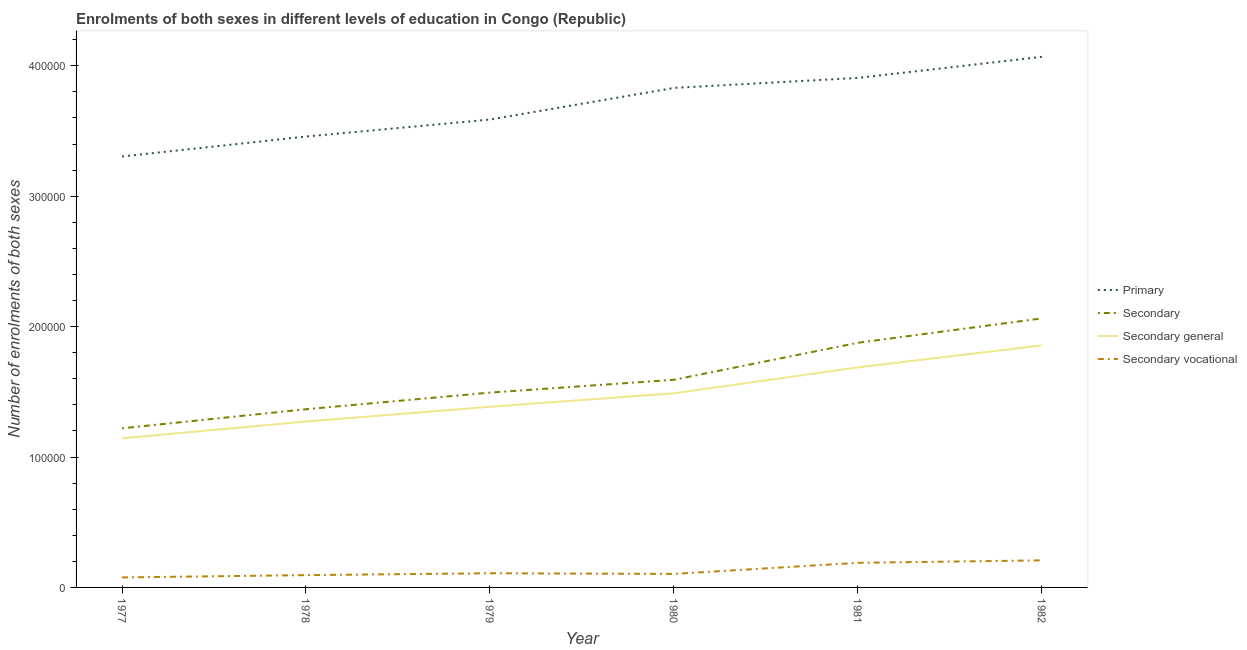How many different coloured lines are there?
Your answer should be very brief. 4. Does the line corresponding to number of enrolments in primary education intersect with the line corresponding to number of enrolments in secondary education?
Keep it short and to the point. No. Is the number of lines equal to the number of legend labels?
Ensure brevity in your answer.  Yes. What is the number of enrolments in primary education in 1978?
Keep it short and to the point. 3.46e+05. Across all years, what is the maximum number of enrolments in secondary vocational education?
Provide a succinct answer. 2.07e+04. Across all years, what is the minimum number of enrolments in secondary education?
Keep it short and to the point. 1.22e+05. In which year was the number of enrolments in secondary education minimum?
Your response must be concise. 1977. What is the total number of enrolments in secondary education in the graph?
Offer a very short reply. 9.61e+05. What is the difference between the number of enrolments in secondary general education in 1979 and that in 1981?
Your response must be concise. -3.02e+04. What is the difference between the number of enrolments in secondary vocational education in 1978 and the number of enrolments in secondary general education in 1980?
Give a very brief answer. -1.39e+05. What is the average number of enrolments in secondary general education per year?
Provide a succinct answer. 1.47e+05. In the year 1981, what is the difference between the number of enrolments in secondary education and number of enrolments in secondary general education?
Ensure brevity in your answer.  1.89e+04. What is the ratio of the number of enrolments in primary education in 1977 to that in 1982?
Offer a very short reply. 0.81. Is the difference between the number of enrolments in secondary education in 1979 and 1981 greater than the difference between the number of enrolments in secondary general education in 1979 and 1981?
Offer a terse response. No. What is the difference between the highest and the second highest number of enrolments in secondary vocational education?
Ensure brevity in your answer.  1877. What is the difference between the highest and the lowest number of enrolments in primary education?
Ensure brevity in your answer.  7.64e+04. Is it the case that in every year, the sum of the number of enrolments in secondary general education and number of enrolments in primary education is greater than the sum of number of enrolments in secondary education and number of enrolments in secondary vocational education?
Your answer should be compact. Yes. What is the difference between two consecutive major ticks on the Y-axis?
Offer a very short reply. 1.00e+05. Does the graph contain any zero values?
Your response must be concise. No. Where does the legend appear in the graph?
Your answer should be very brief. Center right. How many legend labels are there?
Your answer should be very brief. 4. What is the title of the graph?
Make the answer very short. Enrolments of both sexes in different levels of education in Congo (Republic). Does "Social Awareness" appear as one of the legend labels in the graph?
Your response must be concise. No. What is the label or title of the X-axis?
Keep it short and to the point. Year. What is the label or title of the Y-axis?
Your answer should be compact. Number of enrolments of both sexes. What is the Number of enrolments of both sexes of Primary in 1977?
Provide a succinct answer. 3.30e+05. What is the Number of enrolments of both sexes in Secondary in 1977?
Provide a short and direct response. 1.22e+05. What is the Number of enrolments of both sexes in Secondary general in 1977?
Give a very brief answer. 1.14e+05. What is the Number of enrolments of both sexes of Secondary vocational in 1977?
Offer a very short reply. 7665. What is the Number of enrolments of both sexes in Primary in 1978?
Provide a succinct answer. 3.46e+05. What is the Number of enrolments of both sexes in Secondary in 1978?
Make the answer very short. 1.37e+05. What is the Number of enrolments of both sexes of Secondary general in 1978?
Make the answer very short. 1.27e+05. What is the Number of enrolments of both sexes of Secondary vocational in 1978?
Offer a terse response. 9432. What is the Number of enrolments of both sexes of Primary in 1979?
Your response must be concise. 3.59e+05. What is the Number of enrolments of both sexes of Secondary in 1979?
Provide a succinct answer. 1.49e+05. What is the Number of enrolments of both sexes in Secondary general in 1979?
Offer a very short reply. 1.39e+05. What is the Number of enrolments of both sexes of Secondary vocational in 1979?
Your response must be concise. 1.09e+04. What is the Number of enrolments of both sexes in Primary in 1980?
Provide a short and direct response. 3.83e+05. What is the Number of enrolments of both sexes in Secondary in 1980?
Give a very brief answer. 1.59e+05. What is the Number of enrolments of both sexes in Secondary general in 1980?
Keep it short and to the point. 1.49e+05. What is the Number of enrolments of both sexes in Secondary vocational in 1980?
Offer a terse response. 1.04e+04. What is the Number of enrolments of both sexes in Primary in 1981?
Offer a terse response. 3.91e+05. What is the Number of enrolments of both sexes in Secondary in 1981?
Your answer should be very brief. 1.88e+05. What is the Number of enrolments of both sexes in Secondary general in 1981?
Your answer should be compact. 1.69e+05. What is the Number of enrolments of both sexes of Secondary vocational in 1981?
Keep it short and to the point. 1.89e+04. What is the Number of enrolments of both sexes of Primary in 1982?
Your answer should be very brief. 4.07e+05. What is the Number of enrolments of both sexes of Secondary in 1982?
Offer a terse response. 2.06e+05. What is the Number of enrolments of both sexes of Secondary general in 1982?
Provide a short and direct response. 1.86e+05. What is the Number of enrolments of both sexes in Secondary vocational in 1982?
Provide a succinct answer. 2.07e+04. Across all years, what is the maximum Number of enrolments of both sexes in Primary?
Keep it short and to the point. 4.07e+05. Across all years, what is the maximum Number of enrolments of both sexes of Secondary?
Offer a very short reply. 2.06e+05. Across all years, what is the maximum Number of enrolments of both sexes of Secondary general?
Provide a short and direct response. 1.86e+05. Across all years, what is the maximum Number of enrolments of both sexes of Secondary vocational?
Make the answer very short. 2.07e+04. Across all years, what is the minimum Number of enrolments of both sexes in Primary?
Offer a terse response. 3.30e+05. Across all years, what is the minimum Number of enrolments of both sexes of Secondary?
Provide a short and direct response. 1.22e+05. Across all years, what is the minimum Number of enrolments of both sexes in Secondary general?
Ensure brevity in your answer.  1.14e+05. Across all years, what is the minimum Number of enrolments of both sexes in Secondary vocational?
Offer a very short reply. 7665. What is the total Number of enrolments of both sexes of Primary in the graph?
Keep it short and to the point. 2.22e+06. What is the total Number of enrolments of both sexes of Secondary in the graph?
Your answer should be compact. 9.61e+05. What is the total Number of enrolments of both sexes in Secondary general in the graph?
Keep it short and to the point. 8.83e+05. What is the total Number of enrolments of both sexes in Secondary vocational in the graph?
Make the answer very short. 7.79e+04. What is the difference between the Number of enrolments of both sexes in Primary in 1977 and that in 1978?
Make the answer very short. -1.53e+04. What is the difference between the Number of enrolments of both sexes of Secondary in 1977 and that in 1978?
Keep it short and to the point. -1.46e+04. What is the difference between the Number of enrolments of both sexes in Secondary general in 1977 and that in 1978?
Provide a succinct answer. -1.29e+04. What is the difference between the Number of enrolments of both sexes in Secondary vocational in 1977 and that in 1978?
Provide a succinct answer. -1767. What is the difference between the Number of enrolments of both sexes of Primary in 1977 and that in 1979?
Offer a terse response. -2.83e+04. What is the difference between the Number of enrolments of both sexes in Secondary in 1977 and that in 1979?
Make the answer very short. -2.74e+04. What is the difference between the Number of enrolments of both sexes of Secondary general in 1977 and that in 1979?
Make the answer very short. -2.42e+04. What is the difference between the Number of enrolments of both sexes of Secondary vocational in 1977 and that in 1979?
Your answer should be compact. -3196. What is the difference between the Number of enrolments of both sexes in Primary in 1977 and that in 1980?
Give a very brief answer. -5.26e+04. What is the difference between the Number of enrolments of both sexes in Secondary in 1977 and that in 1980?
Keep it short and to the point. -3.72e+04. What is the difference between the Number of enrolments of both sexes of Secondary general in 1977 and that in 1980?
Offer a terse response. -3.45e+04. What is the difference between the Number of enrolments of both sexes of Secondary vocational in 1977 and that in 1980?
Offer a very short reply. -2696. What is the difference between the Number of enrolments of both sexes of Primary in 1977 and that in 1981?
Offer a terse response. -6.02e+04. What is the difference between the Number of enrolments of both sexes of Secondary in 1977 and that in 1981?
Ensure brevity in your answer.  -6.56e+04. What is the difference between the Number of enrolments of both sexes of Secondary general in 1977 and that in 1981?
Provide a short and direct response. -5.44e+04. What is the difference between the Number of enrolments of both sexes of Secondary vocational in 1977 and that in 1981?
Provide a succinct answer. -1.12e+04. What is the difference between the Number of enrolments of both sexes in Primary in 1977 and that in 1982?
Give a very brief answer. -7.64e+04. What is the difference between the Number of enrolments of both sexes of Secondary in 1977 and that in 1982?
Provide a short and direct response. -8.43e+04. What is the difference between the Number of enrolments of both sexes of Secondary general in 1977 and that in 1982?
Your response must be concise. -7.12e+04. What is the difference between the Number of enrolments of both sexes of Secondary vocational in 1977 and that in 1982?
Your answer should be compact. -1.31e+04. What is the difference between the Number of enrolments of both sexes in Primary in 1978 and that in 1979?
Your answer should be compact. -1.30e+04. What is the difference between the Number of enrolments of both sexes of Secondary in 1978 and that in 1979?
Give a very brief answer. -1.27e+04. What is the difference between the Number of enrolments of both sexes of Secondary general in 1978 and that in 1979?
Ensure brevity in your answer.  -1.13e+04. What is the difference between the Number of enrolments of both sexes in Secondary vocational in 1978 and that in 1979?
Provide a short and direct response. -1429. What is the difference between the Number of enrolments of both sexes in Primary in 1978 and that in 1980?
Offer a very short reply. -3.73e+04. What is the difference between the Number of enrolments of both sexes in Secondary in 1978 and that in 1980?
Offer a terse response. -2.26e+04. What is the difference between the Number of enrolments of both sexes in Secondary general in 1978 and that in 1980?
Your answer should be compact. -2.16e+04. What is the difference between the Number of enrolments of both sexes in Secondary vocational in 1978 and that in 1980?
Ensure brevity in your answer.  -929. What is the difference between the Number of enrolments of both sexes in Primary in 1978 and that in 1981?
Your answer should be compact. -4.49e+04. What is the difference between the Number of enrolments of both sexes in Secondary in 1978 and that in 1981?
Offer a very short reply. -5.09e+04. What is the difference between the Number of enrolments of both sexes in Secondary general in 1978 and that in 1981?
Your response must be concise. -4.15e+04. What is the difference between the Number of enrolments of both sexes in Secondary vocational in 1978 and that in 1981?
Offer a terse response. -9435. What is the difference between the Number of enrolments of both sexes of Primary in 1978 and that in 1982?
Give a very brief answer. -6.11e+04. What is the difference between the Number of enrolments of both sexes in Secondary in 1978 and that in 1982?
Your response must be concise. -6.97e+04. What is the difference between the Number of enrolments of both sexes of Secondary general in 1978 and that in 1982?
Make the answer very short. -5.83e+04. What is the difference between the Number of enrolments of both sexes in Secondary vocational in 1978 and that in 1982?
Offer a very short reply. -1.13e+04. What is the difference between the Number of enrolments of both sexes of Primary in 1979 and that in 1980?
Your answer should be compact. -2.43e+04. What is the difference between the Number of enrolments of both sexes in Secondary in 1979 and that in 1980?
Ensure brevity in your answer.  -9832. What is the difference between the Number of enrolments of both sexes of Secondary general in 1979 and that in 1980?
Your answer should be very brief. -1.03e+04. What is the difference between the Number of enrolments of both sexes in Secondary vocational in 1979 and that in 1980?
Your answer should be very brief. 500. What is the difference between the Number of enrolments of both sexes in Primary in 1979 and that in 1981?
Provide a short and direct response. -3.19e+04. What is the difference between the Number of enrolments of both sexes in Secondary in 1979 and that in 1981?
Offer a very short reply. -3.82e+04. What is the difference between the Number of enrolments of both sexes of Secondary general in 1979 and that in 1981?
Your response must be concise. -3.02e+04. What is the difference between the Number of enrolments of both sexes in Secondary vocational in 1979 and that in 1981?
Offer a very short reply. -8006. What is the difference between the Number of enrolments of both sexes in Primary in 1979 and that in 1982?
Offer a very short reply. -4.81e+04. What is the difference between the Number of enrolments of both sexes of Secondary in 1979 and that in 1982?
Provide a short and direct response. -5.69e+04. What is the difference between the Number of enrolments of both sexes in Secondary general in 1979 and that in 1982?
Give a very brief answer. -4.70e+04. What is the difference between the Number of enrolments of both sexes of Secondary vocational in 1979 and that in 1982?
Keep it short and to the point. -9883. What is the difference between the Number of enrolments of both sexes of Primary in 1980 and that in 1981?
Provide a short and direct response. -7658. What is the difference between the Number of enrolments of both sexes of Secondary in 1980 and that in 1981?
Offer a terse response. -2.84e+04. What is the difference between the Number of enrolments of both sexes in Secondary general in 1980 and that in 1981?
Your response must be concise. -1.99e+04. What is the difference between the Number of enrolments of both sexes of Secondary vocational in 1980 and that in 1981?
Ensure brevity in your answer.  -8506. What is the difference between the Number of enrolments of both sexes of Primary in 1980 and that in 1982?
Offer a very short reply. -2.38e+04. What is the difference between the Number of enrolments of both sexes of Secondary in 1980 and that in 1982?
Ensure brevity in your answer.  -4.71e+04. What is the difference between the Number of enrolments of both sexes of Secondary general in 1980 and that in 1982?
Give a very brief answer. -3.67e+04. What is the difference between the Number of enrolments of both sexes of Secondary vocational in 1980 and that in 1982?
Your response must be concise. -1.04e+04. What is the difference between the Number of enrolments of both sexes of Primary in 1981 and that in 1982?
Offer a very short reply. -1.62e+04. What is the difference between the Number of enrolments of both sexes in Secondary in 1981 and that in 1982?
Provide a short and direct response. -1.87e+04. What is the difference between the Number of enrolments of both sexes in Secondary general in 1981 and that in 1982?
Ensure brevity in your answer.  -1.68e+04. What is the difference between the Number of enrolments of both sexes of Secondary vocational in 1981 and that in 1982?
Give a very brief answer. -1877. What is the difference between the Number of enrolments of both sexes of Primary in 1977 and the Number of enrolments of both sexes of Secondary in 1978?
Offer a very short reply. 1.94e+05. What is the difference between the Number of enrolments of both sexes of Primary in 1977 and the Number of enrolments of both sexes of Secondary general in 1978?
Keep it short and to the point. 2.03e+05. What is the difference between the Number of enrolments of both sexes in Primary in 1977 and the Number of enrolments of both sexes in Secondary vocational in 1978?
Your response must be concise. 3.21e+05. What is the difference between the Number of enrolments of both sexes in Secondary in 1977 and the Number of enrolments of both sexes in Secondary general in 1978?
Ensure brevity in your answer.  -5204. What is the difference between the Number of enrolments of both sexes in Secondary in 1977 and the Number of enrolments of both sexes in Secondary vocational in 1978?
Your answer should be compact. 1.13e+05. What is the difference between the Number of enrolments of both sexes of Secondary general in 1977 and the Number of enrolments of both sexes of Secondary vocational in 1978?
Provide a short and direct response. 1.05e+05. What is the difference between the Number of enrolments of both sexes of Primary in 1977 and the Number of enrolments of both sexes of Secondary in 1979?
Your answer should be very brief. 1.81e+05. What is the difference between the Number of enrolments of both sexes of Primary in 1977 and the Number of enrolments of both sexes of Secondary general in 1979?
Give a very brief answer. 1.92e+05. What is the difference between the Number of enrolments of both sexes of Primary in 1977 and the Number of enrolments of both sexes of Secondary vocational in 1979?
Offer a terse response. 3.20e+05. What is the difference between the Number of enrolments of both sexes in Secondary in 1977 and the Number of enrolments of both sexes in Secondary general in 1979?
Provide a succinct answer. -1.65e+04. What is the difference between the Number of enrolments of both sexes in Secondary in 1977 and the Number of enrolments of both sexes in Secondary vocational in 1979?
Keep it short and to the point. 1.11e+05. What is the difference between the Number of enrolments of both sexes in Secondary general in 1977 and the Number of enrolments of both sexes in Secondary vocational in 1979?
Your answer should be very brief. 1.03e+05. What is the difference between the Number of enrolments of both sexes of Primary in 1977 and the Number of enrolments of both sexes of Secondary in 1980?
Your answer should be compact. 1.71e+05. What is the difference between the Number of enrolments of both sexes in Primary in 1977 and the Number of enrolments of both sexes in Secondary general in 1980?
Ensure brevity in your answer.  1.82e+05. What is the difference between the Number of enrolments of both sexes in Primary in 1977 and the Number of enrolments of both sexes in Secondary vocational in 1980?
Provide a short and direct response. 3.20e+05. What is the difference between the Number of enrolments of both sexes in Secondary in 1977 and the Number of enrolments of both sexes in Secondary general in 1980?
Ensure brevity in your answer.  -2.69e+04. What is the difference between the Number of enrolments of both sexes in Secondary in 1977 and the Number of enrolments of both sexes in Secondary vocational in 1980?
Give a very brief answer. 1.12e+05. What is the difference between the Number of enrolments of both sexes in Secondary general in 1977 and the Number of enrolments of both sexes in Secondary vocational in 1980?
Your answer should be compact. 1.04e+05. What is the difference between the Number of enrolments of both sexes of Primary in 1977 and the Number of enrolments of both sexes of Secondary in 1981?
Your answer should be compact. 1.43e+05. What is the difference between the Number of enrolments of both sexes in Primary in 1977 and the Number of enrolments of both sexes in Secondary general in 1981?
Your answer should be compact. 1.62e+05. What is the difference between the Number of enrolments of both sexes in Primary in 1977 and the Number of enrolments of both sexes in Secondary vocational in 1981?
Ensure brevity in your answer.  3.12e+05. What is the difference between the Number of enrolments of both sexes of Secondary in 1977 and the Number of enrolments of both sexes of Secondary general in 1981?
Make the answer very short. -4.67e+04. What is the difference between the Number of enrolments of both sexes in Secondary in 1977 and the Number of enrolments of both sexes in Secondary vocational in 1981?
Your answer should be compact. 1.03e+05. What is the difference between the Number of enrolments of both sexes of Secondary general in 1977 and the Number of enrolments of both sexes of Secondary vocational in 1981?
Ensure brevity in your answer.  9.55e+04. What is the difference between the Number of enrolments of both sexes of Primary in 1977 and the Number of enrolments of both sexes of Secondary in 1982?
Make the answer very short. 1.24e+05. What is the difference between the Number of enrolments of both sexes in Primary in 1977 and the Number of enrolments of both sexes in Secondary general in 1982?
Keep it short and to the point. 1.45e+05. What is the difference between the Number of enrolments of both sexes in Primary in 1977 and the Number of enrolments of both sexes in Secondary vocational in 1982?
Make the answer very short. 3.10e+05. What is the difference between the Number of enrolments of both sexes in Secondary in 1977 and the Number of enrolments of both sexes in Secondary general in 1982?
Make the answer very short. -6.35e+04. What is the difference between the Number of enrolments of both sexes of Secondary in 1977 and the Number of enrolments of both sexes of Secondary vocational in 1982?
Offer a terse response. 1.01e+05. What is the difference between the Number of enrolments of both sexes of Secondary general in 1977 and the Number of enrolments of both sexes of Secondary vocational in 1982?
Provide a short and direct response. 9.36e+04. What is the difference between the Number of enrolments of both sexes in Primary in 1978 and the Number of enrolments of both sexes in Secondary in 1979?
Give a very brief answer. 1.96e+05. What is the difference between the Number of enrolments of both sexes in Primary in 1978 and the Number of enrolments of both sexes in Secondary general in 1979?
Make the answer very short. 2.07e+05. What is the difference between the Number of enrolments of both sexes of Primary in 1978 and the Number of enrolments of both sexes of Secondary vocational in 1979?
Your answer should be compact. 3.35e+05. What is the difference between the Number of enrolments of both sexes in Secondary in 1978 and the Number of enrolments of both sexes in Secondary general in 1979?
Provide a succinct answer. -1883. What is the difference between the Number of enrolments of both sexes in Secondary in 1978 and the Number of enrolments of both sexes in Secondary vocational in 1979?
Make the answer very short. 1.26e+05. What is the difference between the Number of enrolments of both sexes of Secondary general in 1978 and the Number of enrolments of both sexes of Secondary vocational in 1979?
Give a very brief answer. 1.16e+05. What is the difference between the Number of enrolments of both sexes of Primary in 1978 and the Number of enrolments of both sexes of Secondary in 1980?
Provide a succinct answer. 1.87e+05. What is the difference between the Number of enrolments of both sexes of Primary in 1978 and the Number of enrolments of both sexes of Secondary general in 1980?
Your answer should be compact. 1.97e+05. What is the difference between the Number of enrolments of both sexes of Primary in 1978 and the Number of enrolments of both sexes of Secondary vocational in 1980?
Give a very brief answer. 3.35e+05. What is the difference between the Number of enrolments of both sexes in Secondary in 1978 and the Number of enrolments of both sexes in Secondary general in 1980?
Offer a very short reply. -1.22e+04. What is the difference between the Number of enrolments of both sexes in Secondary in 1978 and the Number of enrolments of both sexes in Secondary vocational in 1980?
Your answer should be very brief. 1.26e+05. What is the difference between the Number of enrolments of both sexes in Secondary general in 1978 and the Number of enrolments of both sexes in Secondary vocational in 1980?
Make the answer very short. 1.17e+05. What is the difference between the Number of enrolments of both sexes in Primary in 1978 and the Number of enrolments of both sexes in Secondary in 1981?
Provide a short and direct response. 1.58e+05. What is the difference between the Number of enrolments of both sexes in Primary in 1978 and the Number of enrolments of both sexes in Secondary general in 1981?
Provide a short and direct response. 1.77e+05. What is the difference between the Number of enrolments of both sexes of Primary in 1978 and the Number of enrolments of both sexes of Secondary vocational in 1981?
Your response must be concise. 3.27e+05. What is the difference between the Number of enrolments of both sexes in Secondary in 1978 and the Number of enrolments of both sexes in Secondary general in 1981?
Provide a short and direct response. -3.21e+04. What is the difference between the Number of enrolments of both sexes of Secondary in 1978 and the Number of enrolments of both sexes of Secondary vocational in 1981?
Offer a very short reply. 1.18e+05. What is the difference between the Number of enrolments of both sexes of Secondary general in 1978 and the Number of enrolments of both sexes of Secondary vocational in 1981?
Make the answer very short. 1.08e+05. What is the difference between the Number of enrolments of both sexes of Primary in 1978 and the Number of enrolments of both sexes of Secondary in 1982?
Your response must be concise. 1.39e+05. What is the difference between the Number of enrolments of both sexes of Primary in 1978 and the Number of enrolments of both sexes of Secondary general in 1982?
Your answer should be very brief. 1.60e+05. What is the difference between the Number of enrolments of both sexes of Primary in 1978 and the Number of enrolments of both sexes of Secondary vocational in 1982?
Offer a very short reply. 3.25e+05. What is the difference between the Number of enrolments of both sexes in Secondary in 1978 and the Number of enrolments of both sexes in Secondary general in 1982?
Ensure brevity in your answer.  -4.89e+04. What is the difference between the Number of enrolments of both sexes in Secondary in 1978 and the Number of enrolments of both sexes in Secondary vocational in 1982?
Your answer should be compact. 1.16e+05. What is the difference between the Number of enrolments of both sexes of Secondary general in 1978 and the Number of enrolments of both sexes of Secondary vocational in 1982?
Make the answer very short. 1.06e+05. What is the difference between the Number of enrolments of both sexes in Primary in 1979 and the Number of enrolments of both sexes in Secondary in 1980?
Your answer should be very brief. 2.00e+05. What is the difference between the Number of enrolments of both sexes in Primary in 1979 and the Number of enrolments of both sexes in Secondary general in 1980?
Your answer should be compact. 2.10e+05. What is the difference between the Number of enrolments of both sexes of Primary in 1979 and the Number of enrolments of both sexes of Secondary vocational in 1980?
Make the answer very short. 3.48e+05. What is the difference between the Number of enrolments of both sexes of Secondary in 1979 and the Number of enrolments of both sexes of Secondary general in 1980?
Offer a very short reply. 529. What is the difference between the Number of enrolments of both sexes in Secondary in 1979 and the Number of enrolments of both sexes in Secondary vocational in 1980?
Your answer should be very brief. 1.39e+05. What is the difference between the Number of enrolments of both sexes of Secondary general in 1979 and the Number of enrolments of both sexes of Secondary vocational in 1980?
Your answer should be very brief. 1.28e+05. What is the difference between the Number of enrolments of both sexes of Primary in 1979 and the Number of enrolments of both sexes of Secondary in 1981?
Offer a terse response. 1.71e+05. What is the difference between the Number of enrolments of both sexes in Primary in 1979 and the Number of enrolments of both sexes in Secondary general in 1981?
Provide a short and direct response. 1.90e+05. What is the difference between the Number of enrolments of both sexes in Primary in 1979 and the Number of enrolments of both sexes in Secondary vocational in 1981?
Give a very brief answer. 3.40e+05. What is the difference between the Number of enrolments of both sexes in Secondary in 1979 and the Number of enrolments of both sexes in Secondary general in 1981?
Your response must be concise. -1.93e+04. What is the difference between the Number of enrolments of both sexes in Secondary in 1979 and the Number of enrolments of both sexes in Secondary vocational in 1981?
Keep it short and to the point. 1.31e+05. What is the difference between the Number of enrolments of both sexes of Secondary general in 1979 and the Number of enrolments of both sexes of Secondary vocational in 1981?
Your answer should be compact. 1.20e+05. What is the difference between the Number of enrolments of both sexes in Primary in 1979 and the Number of enrolments of both sexes in Secondary in 1982?
Make the answer very short. 1.52e+05. What is the difference between the Number of enrolments of both sexes in Primary in 1979 and the Number of enrolments of both sexes in Secondary general in 1982?
Provide a succinct answer. 1.73e+05. What is the difference between the Number of enrolments of both sexes in Primary in 1979 and the Number of enrolments of both sexes in Secondary vocational in 1982?
Ensure brevity in your answer.  3.38e+05. What is the difference between the Number of enrolments of both sexes in Secondary in 1979 and the Number of enrolments of both sexes in Secondary general in 1982?
Your answer should be very brief. -3.62e+04. What is the difference between the Number of enrolments of both sexes of Secondary in 1979 and the Number of enrolments of both sexes of Secondary vocational in 1982?
Make the answer very short. 1.29e+05. What is the difference between the Number of enrolments of both sexes of Secondary general in 1979 and the Number of enrolments of both sexes of Secondary vocational in 1982?
Keep it short and to the point. 1.18e+05. What is the difference between the Number of enrolments of both sexes in Primary in 1980 and the Number of enrolments of both sexes in Secondary in 1981?
Provide a succinct answer. 1.95e+05. What is the difference between the Number of enrolments of both sexes in Primary in 1980 and the Number of enrolments of both sexes in Secondary general in 1981?
Provide a short and direct response. 2.14e+05. What is the difference between the Number of enrolments of both sexes in Primary in 1980 and the Number of enrolments of both sexes in Secondary vocational in 1981?
Your response must be concise. 3.64e+05. What is the difference between the Number of enrolments of both sexes of Secondary in 1980 and the Number of enrolments of both sexes of Secondary general in 1981?
Provide a short and direct response. -9500. What is the difference between the Number of enrolments of both sexes in Secondary in 1980 and the Number of enrolments of both sexes in Secondary vocational in 1981?
Provide a short and direct response. 1.40e+05. What is the difference between the Number of enrolments of both sexes of Secondary general in 1980 and the Number of enrolments of both sexes of Secondary vocational in 1981?
Your response must be concise. 1.30e+05. What is the difference between the Number of enrolments of both sexes of Primary in 1980 and the Number of enrolments of both sexes of Secondary in 1982?
Offer a terse response. 1.77e+05. What is the difference between the Number of enrolments of both sexes in Primary in 1980 and the Number of enrolments of both sexes in Secondary general in 1982?
Offer a very short reply. 1.97e+05. What is the difference between the Number of enrolments of both sexes of Primary in 1980 and the Number of enrolments of both sexes of Secondary vocational in 1982?
Give a very brief answer. 3.62e+05. What is the difference between the Number of enrolments of both sexes of Secondary in 1980 and the Number of enrolments of both sexes of Secondary general in 1982?
Your answer should be compact. -2.63e+04. What is the difference between the Number of enrolments of both sexes in Secondary in 1980 and the Number of enrolments of both sexes in Secondary vocational in 1982?
Keep it short and to the point. 1.38e+05. What is the difference between the Number of enrolments of both sexes of Secondary general in 1980 and the Number of enrolments of both sexes of Secondary vocational in 1982?
Provide a succinct answer. 1.28e+05. What is the difference between the Number of enrolments of both sexes in Primary in 1981 and the Number of enrolments of both sexes in Secondary in 1982?
Offer a terse response. 1.84e+05. What is the difference between the Number of enrolments of both sexes in Primary in 1981 and the Number of enrolments of both sexes in Secondary general in 1982?
Ensure brevity in your answer.  2.05e+05. What is the difference between the Number of enrolments of both sexes of Primary in 1981 and the Number of enrolments of both sexes of Secondary vocational in 1982?
Keep it short and to the point. 3.70e+05. What is the difference between the Number of enrolments of both sexes in Secondary in 1981 and the Number of enrolments of both sexes in Secondary general in 1982?
Your answer should be very brief. 2030. What is the difference between the Number of enrolments of both sexes of Secondary in 1981 and the Number of enrolments of both sexes of Secondary vocational in 1982?
Offer a very short reply. 1.67e+05. What is the difference between the Number of enrolments of both sexes in Secondary general in 1981 and the Number of enrolments of both sexes in Secondary vocational in 1982?
Give a very brief answer. 1.48e+05. What is the average Number of enrolments of both sexes of Primary per year?
Ensure brevity in your answer.  3.69e+05. What is the average Number of enrolments of both sexes of Secondary per year?
Provide a succinct answer. 1.60e+05. What is the average Number of enrolments of both sexes of Secondary general per year?
Your answer should be very brief. 1.47e+05. What is the average Number of enrolments of both sexes in Secondary vocational per year?
Offer a terse response. 1.30e+04. In the year 1977, what is the difference between the Number of enrolments of both sexes in Primary and Number of enrolments of both sexes in Secondary?
Offer a terse response. 2.08e+05. In the year 1977, what is the difference between the Number of enrolments of both sexes in Primary and Number of enrolments of both sexes in Secondary general?
Your answer should be very brief. 2.16e+05. In the year 1977, what is the difference between the Number of enrolments of both sexes in Primary and Number of enrolments of both sexes in Secondary vocational?
Ensure brevity in your answer.  3.23e+05. In the year 1977, what is the difference between the Number of enrolments of both sexes in Secondary and Number of enrolments of both sexes in Secondary general?
Offer a very short reply. 7665. In the year 1977, what is the difference between the Number of enrolments of both sexes in Secondary and Number of enrolments of both sexes in Secondary vocational?
Ensure brevity in your answer.  1.14e+05. In the year 1977, what is the difference between the Number of enrolments of both sexes of Secondary general and Number of enrolments of both sexes of Secondary vocational?
Provide a short and direct response. 1.07e+05. In the year 1978, what is the difference between the Number of enrolments of both sexes of Primary and Number of enrolments of both sexes of Secondary?
Keep it short and to the point. 2.09e+05. In the year 1978, what is the difference between the Number of enrolments of both sexes in Primary and Number of enrolments of both sexes in Secondary general?
Provide a short and direct response. 2.19e+05. In the year 1978, what is the difference between the Number of enrolments of both sexes of Primary and Number of enrolments of both sexes of Secondary vocational?
Offer a terse response. 3.36e+05. In the year 1978, what is the difference between the Number of enrolments of both sexes in Secondary and Number of enrolments of both sexes in Secondary general?
Offer a very short reply. 9432. In the year 1978, what is the difference between the Number of enrolments of both sexes in Secondary and Number of enrolments of both sexes in Secondary vocational?
Provide a short and direct response. 1.27e+05. In the year 1978, what is the difference between the Number of enrolments of both sexes of Secondary general and Number of enrolments of both sexes of Secondary vocational?
Offer a very short reply. 1.18e+05. In the year 1979, what is the difference between the Number of enrolments of both sexes in Primary and Number of enrolments of both sexes in Secondary?
Provide a succinct answer. 2.09e+05. In the year 1979, what is the difference between the Number of enrolments of both sexes of Primary and Number of enrolments of both sexes of Secondary general?
Provide a succinct answer. 2.20e+05. In the year 1979, what is the difference between the Number of enrolments of both sexes of Primary and Number of enrolments of both sexes of Secondary vocational?
Ensure brevity in your answer.  3.48e+05. In the year 1979, what is the difference between the Number of enrolments of both sexes of Secondary and Number of enrolments of both sexes of Secondary general?
Your response must be concise. 1.09e+04. In the year 1979, what is the difference between the Number of enrolments of both sexes of Secondary and Number of enrolments of both sexes of Secondary vocational?
Make the answer very short. 1.39e+05. In the year 1979, what is the difference between the Number of enrolments of both sexes in Secondary general and Number of enrolments of both sexes in Secondary vocational?
Your response must be concise. 1.28e+05. In the year 1980, what is the difference between the Number of enrolments of both sexes of Primary and Number of enrolments of both sexes of Secondary?
Make the answer very short. 2.24e+05. In the year 1980, what is the difference between the Number of enrolments of both sexes in Primary and Number of enrolments of both sexes in Secondary general?
Provide a succinct answer. 2.34e+05. In the year 1980, what is the difference between the Number of enrolments of both sexes of Primary and Number of enrolments of both sexes of Secondary vocational?
Your response must be concise. 3.73e+05. In the year 1980, what is the difference between the Number of enrolments of both sexes of Secondary and Number of enrolments of both sexes of Secondary general?
Ensure brevity in your answer.  1.04e+04. In the year 1980, what is the difference between the Number of enrolments of both sexes of Secondary and Number of enrolments of both sexes of Secondary vocational?
Your answer should be very brief. 1.49e+05. In the year 1980, what is the difference between the Number of enrolments of both sexes in Secondary general and Number of enrolments of both sexes in Secondary vocational?
Provide a succinct answer. 1.38e+05. In the year 1981, what is the difference between the Number of enrolments of both sexes of Primary and Number of enrolments of both sexes of Secondary?
Your response must be concise. 2.03e+05. In the year 1981, what is the difference between the Number of enrolments of both sexes of Primary and Number of enrolments of both sexes of Secondary general?
Your answer should be compact. 2.22e+05. In the year 1981, what is the difference between the Number of enrolments of both sexes of Primary and Number of enrolments of both sexes of Secondary vocational?
Keep it short and to the point. 3.72e+05. In the year 1981, what is the difference between the Number of enrolments of both sexes of Secondary and Number of enrolments of both sexes of Secondary general?
Your answer should be compact. 1.89e+04. In the year 1981, what is the difference between the Number of enrolments of both sexes in Secondary and Number of enrolments of both sexes in Secondary vocational?
Provide a succinct answer. 1.69e+05. In the year 1981, what is the difference between the Number of enrolments of both sexes of Secondary general and Number of enrolments of both sexes of Secondary vocational?
Give a very brief answer. 1.50e+05. In the year 1982, what is the difference between the Number of enrolments of both sexes in Primary and Number of enrolments of both sexes in Secondary?
Offer a terse response. 2.01e+05. In the year 1982, what is the difference between the Number of enrolments of both sexes in Primary and Number of enrolments of both sexes in Secondary general?
Offer a terse response. 2.21e+05. In the year 1982, what is the difference between the Number of enrolments of both sexes in Primary and Number of enrolments of both sexes in Secondary vocational?
Give a very brief answer. 3.86e+05. In the year 1982, what is the difference between the Number of enrolments of both sexes of Secondary and Number of enrolments of both sexes of Secondary general?
Ensure brevity in your answer.  2.07e+04. In the year 1982, what is the difference between the Number of enrolments of both sexes of Secondary and Number of enrolments of both sexes of Secondary vocational?
Provide a short and direct response. 1.86e+05. In the year 1982, what is the difference between the Number of enrolments of both sexes in Secondary general and Number of enrolments of both sexes in Secondary vocational?
Make the answer very short. 1.65e+05. What is the ratio of the Number of enrolments of both sexes of Primary in 1977 to that in 1978?
Offer a very short reply. 0.96. What is the ratio of the Number of enrolments of both sexes in Secondary in 1977 to that in 1978?
Make the answer very short. 0.89. What is the ratio of the Number of enrolments of both sexes of Secondary general in 1977 to that in 1978?
Offer a very short reply. 0.9. What is the ratio of the Number of enrolments of both sexes of Secondary vocational in 1977 to that in 1978?
Provide a short and direct response. 0.81. What is the ratio of the Number of enrolments of both sexes of Primary in 1977 to that in 1979?
Make the answer very short. 0.92. What is the ratio of the Number of enrolments of both sexes of Secondary in 1977 to that in 1979?
Ensure brevity in your answer.  0.82. What is the ratio of the Number of enrolments of both sexes in Secondary general in 1977 to that in 1979?
Your answer should be very brief. 0.83. What is the ratio of the Number of enrolments of both sexes in Secondary vocational in 1977 to that in 1979?
Your answer should be very brief. 0.71. What is the ratio of the Number of enrolments of both sexes of Primary in 1977 to that in 1980?
Your response must be concise. 0.86. What is the ratio of the Number of enrolments of both sexes of Secondary in 1977 to that in 1980?
Offer a terse response. 0.77. What is the ratio of the Number of enrolments of both sexes of Secondary general in 1977 to that in 1980?
Your response must be concise. 0.77. What is the ratio of the Number of enrolments of both sexes of Secondary vocational in 1977 to that in 1980?
Your answer should be compact. 0.74. What is the ratio of the Number of enrolments of both sexes of Primary in 1977 to that in 1981?
Offer a very short reply. 0.85. What is the ratio of the Number of enrolments of both sexes of Secondary in 1977 to that in 1981?
Your response must be concise. 0.65. What is the ratio of the Number of enrolments of both sexes of Secondary general in 1977 to that in 1981?
Your response must be concise. 0.68. What is the ratio of the Number of enrolments of both sexes of Secondary vocational in 1977 to that in 1981?
Your answer should be very brief. 0.41. What is the ratio of the Number of enrolments of both sexes in Primary in 1977 to that in 1982?
Keep it short and to the point. 0.81. What is the ratio of the Number of enrolments of both sexes in Secondary in 1977 to that in 1982?
Your answer should be very brief. 0.59. What is the ratio of the Number of enrolments of both sexes in Secondary general in 1977 to that in 1982?
Ensure brevity in your answer.  0.62. What is the ratio of the Number of enrolments of both sexes of Secondary vocational in 1977 to that in 1982?
Provide a succinct answer. 0.37. What is the ratio of the Number of enrolments of both sexes in Primary in 1978 to that in 1979?
Offer a very short reply. 0.96. What is the ratio of the Number of enrolments of both sexes of Secondary in 1978 to that in 1979?
Make the answer very short. 0.91. What is the ratio of the Number of enrolments of both sexes in Secondary general in 1978 to that in 1979?
Provide a succinct answer. 0.92. What is the ratio of the Number of enrolments of both sexes of Secondary vocational in 1978 to that in 1979?
Offer a terse response. 0.87. What is the ratio of the Number of enrolments of both sexes in Primary in 1978 to that in 1980?
Ensure brevity in your answer.  0.9. What is the ratio of the Number of enrolments of both sexes of Secondary in 1978 to that in 1980?
Your answer should be compact. 0.86. What is the ratio of the Number of enrolments of both sexes of Secondary general in 1978 to that in 1980?
Your answer should be compact. 0.85. What is the ratio of the Number of enrolments of both sexes of Secondary vocational in 1978 to that in 1980?
Offer a very short reply. 0.91. What is the ratio of the Number of enrolments of both sexes of Primary in 1978 to that in 1981?
Provide a succinct answer. 0.89. What is the ratio of the Number of enrolments of both sexes in Secondary in 1978 to that in 1981?
Give a very brief answer. 0.73. What is the ratio of the Number of enrolments of both sexes of Secondary general in 1978 to that in 1981?
Ensure brevity in your answer.  0.75. What is the ratio of the Number of enrolments of both sexes of Secondary vocational in 1978 to that in 1981?
Offer a terse response. 0.5. What is the ratio of the Number of enrolments of both sexes of Primary in 1978 to that in 1982?
Ensure brevity in your answer.  0.85. What is the ratio of the Number of enrolments of both sexes of Secondary in 1978 to that in 1982?
Offer a very short reply. 0.66. What is the ratio of the Number of enrolments of both sexes of Secondary general in 1978 to that in 1982?
Ensure brevity in your answer.  0.69. What is the ratio of the Number of enrolments of both sexes of Secondary vocational in 1978 to that in 1982?
Your answer should be compact. 0.45. What is the ratio of the Number of enrolments of both sexes in Primary in 1979 to that in 1980?
Provide a short and direct response. 0.94. What is the ratio of the Number of enrolments of both sexes in Secondary in 1979 to that in 1980?
Provide a short and direct response. 0.94. What is the ratio of the Number of enrolments of both sexes of Secondary general in 1979 to that in 1980?
Offer a very short reply. 0.93. What is the ratio of the Number of enrolments of both sexes of Secondary vocational in 1979 to that in 1980?
Give a very brief answer. 1.05. What is the ratio of the Number of enrolments of both sexes of Primary in 1979 to that in 1981?
Provide a short and direct response. 0.92. What is the ratio of the Number of enrolments of both sexes in Secondary in 1979 to that in 1981?
Provide a succinct answer. 0.8. What is the ratio of the Number of enrolments of both sexes in Secondary general in 1979 to that in 1981?
Provide a succinct answer. 0.82. What is the ratio of the Number of enrolments of both sexes of Secondary vocational in 1979 to that in 1981?
Provide a short and direct response. 0.58. What is the ratio of the Number of enrolments of both sexes of Primary in 1979 to that in 1982?
Ensure brevity in your answer.  0.88. What is the ratio of the Number of enrolments of both sexes of Secondary in 1979 to that in 1982?
Offer a terse response. 0.72. What is the ratio of the Number of enrolments of both sexes of Secondary general in 1979 to that in 1982?
Your answer should be very brief. 0.75. What is the ratio of the Number of enrolments of both sexes in Secondary vocational in 1979 to that in 1982?
Offer a very short reply. 0.52. What is the ratio of the Number of enrolments of both sexes in Primary in 1980 to that in 1981?
Ensure brevity in your answer.  0.98. What is the ratio of the Number of enrolments of both sexes of Secondary in 1980 to that in 1981?
Offer a terse response. 0.85. What is the ratio of the Number of enrolments of both sexes of Secondary general in 1980 to that in 1981?
Your answer should be very brief. 0.88. What is the ratio of the Number of enrolments of both sexes of Secondary vocational in 1980 to that in 1981?
Offer a terse response. 0.55. What is the ratio of the Number of enrolments of both sexes in Primary in 1980 to that in 1982?
Offer a terse response. 0.94. What is the ratio of the Number of enrolments of both sexes of Secondary in 1980 to that in 1982?
Your response must be concise. 0.77. What is the ratio of the Number of enrolments of both sexes of Secondary general in 1980 to that in 1982?
Provide a succinct answer. 0.8. What is the ratio of the Number of enrolments of both sexes in Secondary vocational in 1980 to that in 1982?
Offer a very short reply. 0.5. What is the ratio of the Number of enrolments of both sexes in Primary in 1981 to that in 1982?
Your answer should be very brief. 0.96. What is the ratio of the Number of enrolments of both sexes of Secondary in 1981 to that in 1982?
Offer a terse response. 0.91. What is the ratio of the Number of enrolments of both sexes in Secondary general in 1981 to that in 1982?
Make the answer very short. 0.91. What is the ratio of the Number of enrolments of both sexes in Secondary vocational in 1981 to that in 1982?
Offer a very short reply. 0.91. What is the difference between the highest and the second highest Number of enrolments of both sexes in Primary?
Make the answer very short. 1.62e+04. What is the difference between the highest and the second highest Number of enrolments of both sexes in Secondary?
Ensure brevity in your answer.  1.87e+04. What is the difference between the highest and the second highest Number of enrolments of both sexes of Secondary general?
Offer a terse response. 1.68e+04. What is the difference between the highest and the second highest Number of enrolments of both sexes of Secondary vocational?
Make the answer very short. 1877. What is the difference between the highest and the lowest Number of enrolments of both sexes of Primary?
Offer a very short reply. 7.64e+04. What is the difference between the highest and the lowest Number of enrolments of both sexes in Secondary?
Keep it short and to the point. 8.43e+04. What is the difference between the highest and the lowest Number of enrolments of both sexes in Secondary general?
Make the answer very short. 7.12e+04. What is the difference between the highest and the lowest Number of enrolments of both sexes in Secondary vocational?
Provide a short and direct response. 1.31e+04. 